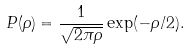<formula> <loc_0><loc_0><loc_500><loc_500>P ( \rho ) = \frac { 1 } { \sqrt { 2 \pi \rho } } \exp ( - \rho / 2 ) .</formula> 